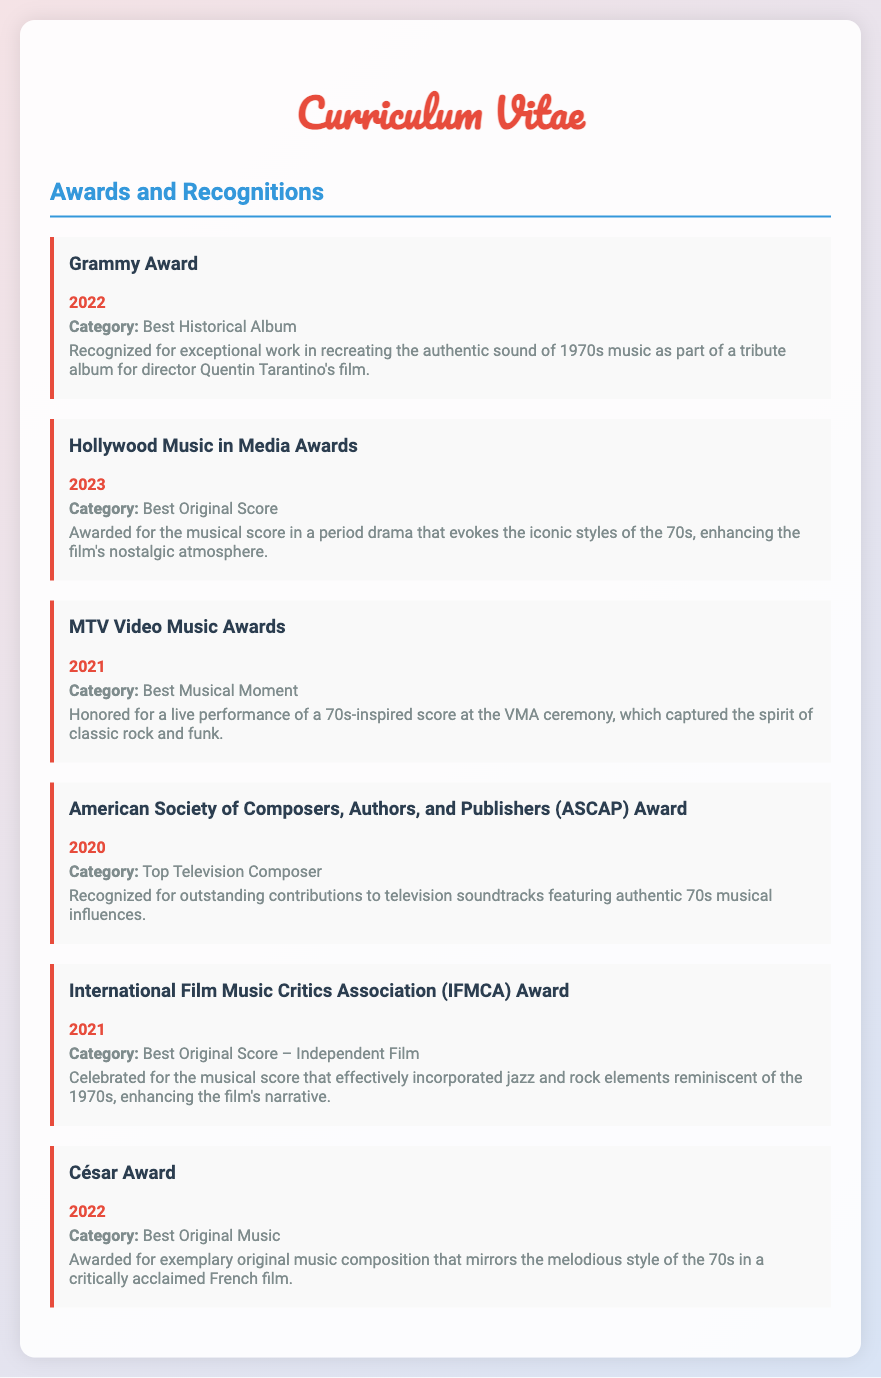What award was received in 2022? The document lists various awards, and the 2022 award mentioned is the Grammy Award.
Answer: Grammy Award What category was awarded at the Hollywood Music in Media Awards in 2023? The document specifies that the 2023 award category is Best Original Score.
Answer: Best Original Score Which award recognizes contributions to television soundtracks? The American Society of Composers, Authors, and Publishers (ASCAP) Award acknowledges outstanding contributions to television soundtracks.
Answer: ASCAP Award How many awards are listed in the document? The document contains details about six different awards.
Answer: 6 What musical elements were highlighted in the International Film Music Critics Association Award in 2021? The award celebrated the incorporation of jazz and rock elements reminiscent of the 1970s in its score.
Answer: Jazz and rock elements Which film director was associated with the Grammy Award for Best Historical Album? The document mentions that the Grammy Award was for a tribute album for director Quentin Tarantino's film.
Answer: Quentin Tarantino What year did the MTV Video Music Awards honor a live performance of a 70s-inspired score? The document states that the MTV Video Music Awards awarded this honor in 2021.
Answer: 2021 Which award is given for exceptional work in recreating the 70s music sound? The Grammy Award is specifically recognized for this exceptional work in the document.
Answer: Grammy Award 